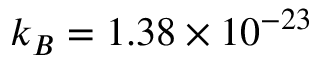Convert formula to latex. <formula><loc_0><loc_0><loc_500><loc_500>k _ { B } = 1 . 3 8 \times 1 0 ^ { - 2 3 }</formula> 